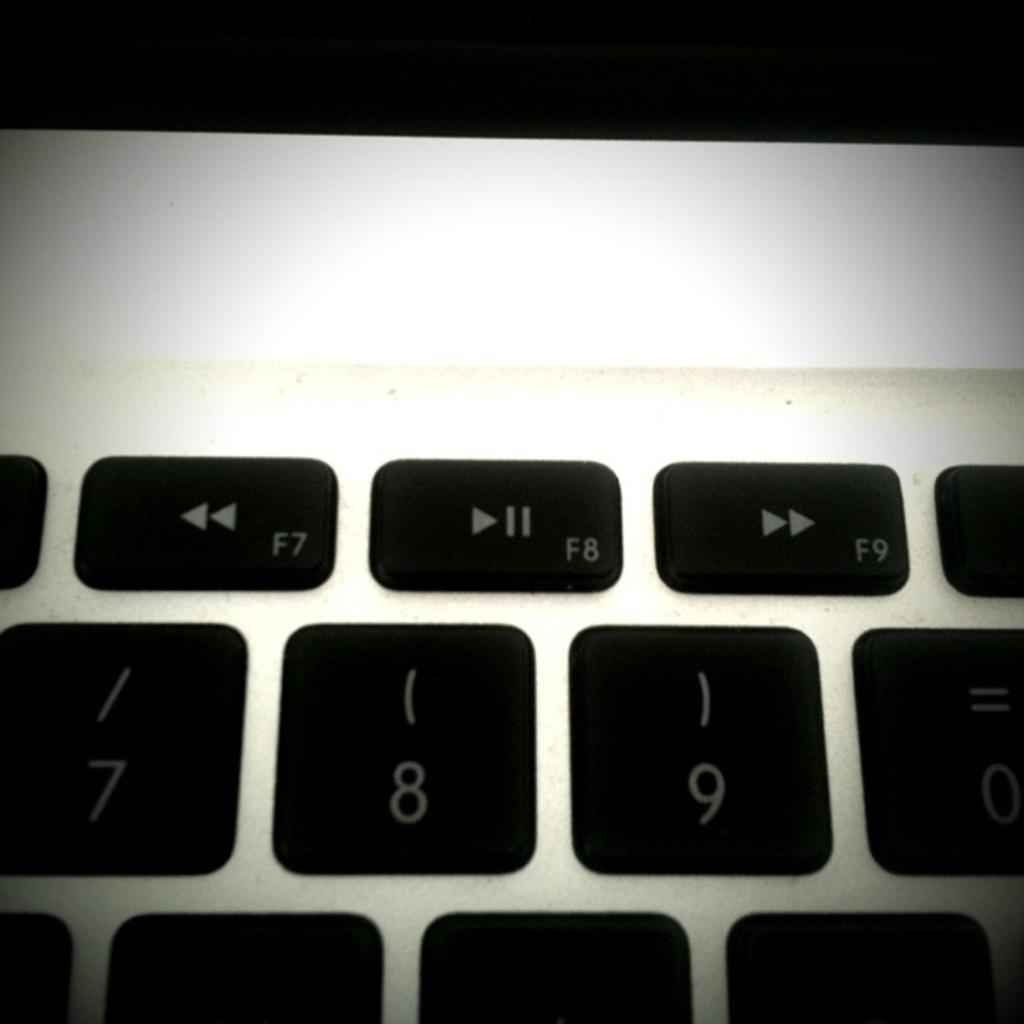What is the main object in the image? There is a keyboard in the image. What are the primary features of the keyboard? The keyboard has keys and numbers on it. How many lizards can be seen playing the keyboard in the image? There are no lizards present in the image, and therefore no such activity can be observed. What type of rhythm is the keyboard producing in the image? The image does not depict any sound or rhythm being produced by the keyboard. 